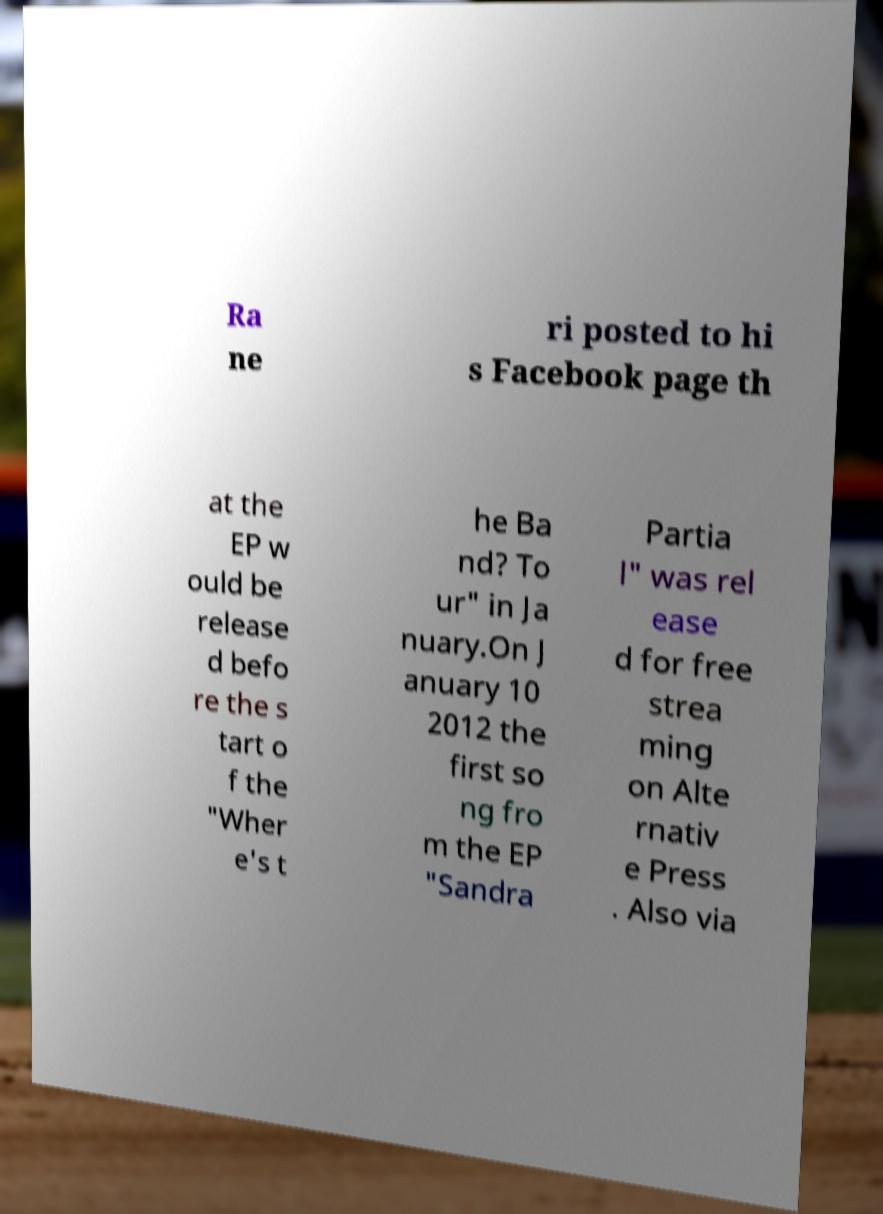Please read and relay the text visible in this image. What does it say? Ra ne ri posted to hi s Facebook page th at the EP w ould be release d befo re the s tart o f the "Wher e's t he Ba nd? To ur" in Ja nuary.On J anuary 10 2012 the first so ng fro m the EP "Sandra Partia l" was rel ease d for free strea ming on Alte rnativ e Press . Also via 